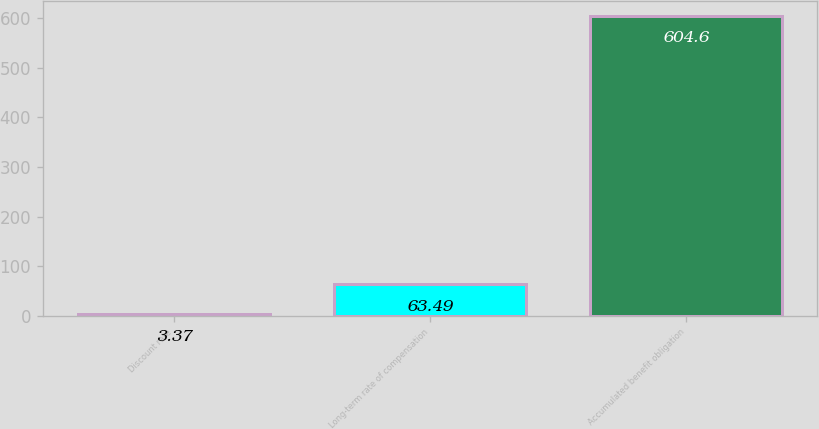Convert chart to OTSL. <chart><loc_0><loc_0><loc_500><loc_500><bar_chart><fcel>Discount rate<fcel>Long-term rate of compensation<fcel>Accumulated benefit obligation<nl><fcel>3.37<fcel>63.49<fcel>604.6<nl></chart> 